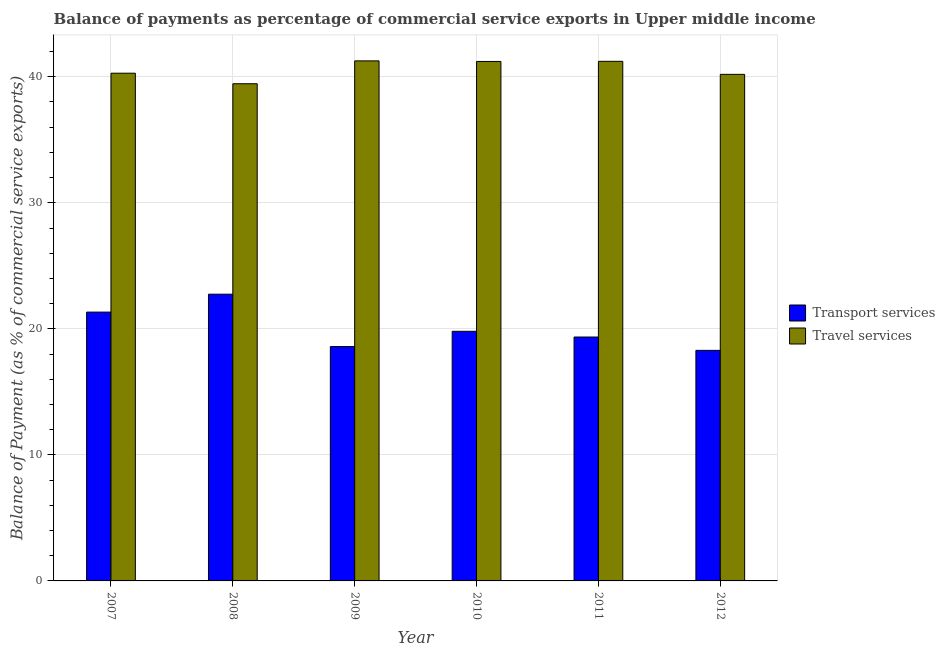How many groups of bars are there?
Provide a succinct answer. 6. Are the number of bars per tick equal to the number of legend labels?
Keep it short and to the point. Yes. Are the number of bars on each tick of the X-axis equal?
Provide a succinct answer. Yes. In how many cases, is the number of bars for a given year not equal to the number of legend labels?
Your answer should be compact. 0. What is the balance of payments of travel services in 2010?
Provide a succinct answer. 41.22. Across all years, what is the maximum balance of payments of travel services?
Your answer should be very brief. 41.26. Across all years, what is the minimum balance of payments of transport services?
Provide a succinct answer. 18.29. In which year was the balance of payments of transport services maximum?
Keep it short and to the point. 2008. In which year was the balance of payments of travel services minimum?
Provide a succinct answer. 2008. What is the total balance of payments of travel services in the graph?
Keep it short and to the point. 243.63. What is the difference between the balance of payments of travel services in 2007 and that in 2011?
Give a very brief answer. -0.94. What is the difference between the balance of payments of travel services in 2011 and the balance of payments of transport services in 2009?
Keep it short and to the point. -0.04. What is the average balance of payments of travel services per year?
Provide a short and direct response. 40.61. What is the ratio of the balance of payments of travel services in 2010 to that in 2011?
Give a very brief answer. 1. Is the balance of payments of transport services in 2011 less than that in 2012?
Give a very brief answer. No. What is the difference between the highest and the second highest balance of payments of transport services?
Provide a short and direct response. 1.42. What is the difference between the highest and the lowest balance of payments of travel services?
Offer a terse response. 1.81. In how many years, is the balance of payments of transport services greater than the average balance of payments of transport services taken over all years?
Offer a terse response. 2. What does the 1st bar from the left in 2008 represents?
Ensure brevity in your answer.  Transport services. What does the 1st bar from the right in 2007 represents?
Your answer should be very brief. Travel services. Are all the bars in the graph horizontal?
Your response must be concise. No. Are the values on the major ticks of Y-axis written in scientific E-notation?
Make the answer very short. No. Where does the legend appear in the graph?
Make the answer very short. Center right. How are the legend labels stacked?
Your answer should be compact. Vertical. What is the title of the graph?
Offer a very short reply. Balance of payments as percentage of commercial service exports in Upper middle income. What is the label or title of the X-axis?
Offer a very short reply. Year. What is the label or title of the Y-axis?
Provide a short and direct response. Balance of Payment (as % of commercial service exports). What is the Balance of Payment (as % of commercial service exports) in Transport services in 2007?
Your answer should be very brief. 21.33. What is the Balance of Payment (as % of commercial service exports) of Travel services in 2007?
Provide a succinct answer. 40.28. What is the Balance of Payment (as % of commercial service exports) in Transport services in 2008?
Offer a very short reply. 22.75. What is the Balance of Payment (as % of commercial service exports) of Travel services in 2008?
Provide a succinct answer. 39.45. What is the Balance of Payment (as % of commercial service exports) in Transport services in 2009?
Your response must be concise. 18.59. What is the Balance of Payment (as % of commercial service exports) in Travel services in 2009?
Keep it short and to the point. 41.26. What is the Balance of Payment (as % of commercial service exports) of Transport services in 2010?
Your answer should be very brief. 19.81. What is the Balance of Payment (as % of commercial service exports) of Travel services in 2010?
Offer a very short reply. 41.22. What is the Balance of Payment (as % of commercial service exports) of Transport services in 2011?
Make the answer very short. 19.35. What is the Balance of Payment (as % of commercial service exports) of Travel services in 2011?
Provide a short and direct response. 41.23. What is the Balance of Payment (as % of commercial service exports) of Transport services in 2012?
Offer a terse response. 18.29. What is the Balance of Payment (as % of commercial service exports) of Travel services in 2012?
Your response must be concise. 40.19. Across all years, what is the maximum Balance of Payment (as % of commercial service exports) in Transport services?
Provide a succinct answer. 22.75. Across all years, what is the maximum Balance of Payment (as % of commercial service exports) of Travel services?
Your answer should be very brief. 41.26. Across all years, what is the minimum Balance of Payment (as % of commercial service exports) of Transport services?
Offer a terse response. 18.29. Across all years, what is the minimum Balance of Payment (as % of commercial service exports) in Travel services?
Your answer should be very brief. 39.45. What is the total Balance of Payment (as % of commercial service exports) in Transport services in the graph?
Your response must be concise. 120.12. What is the total Balance of Payment (as % of commercial service exports) of Travel services in the graph?
Make the answer very short. 243.63. What is the difference between the Balance of Payment (as % of commercial service exports) in Transport services in 2007 and that in 2008?
Give a very brief answer. -1.42. What is the difference between the Balance of Payment (as % of commercial service exports) of Travel services in 2007 and that in 2008?
Provide a short and direct response. 0.84. What is the difference between the Balance of Payment (as % of commercial service exports) of Transport services in 2007 and that in 2009?
Your answer should be very brief. 2.73. What is the difference between the Balance of Payment (as % of commercial service exports) of Travel services in 2007 and that in 2009?
Offer a terse response. -0.98. What is the difference between the Balance of Payment (as % of commercial service exports) of Transport services in 2007 and that in 2010?
Provide a short and direct response. 1.52. What is the difference between the Balance of Payment (as % of commercial service exports) of Travel services in 2007 and that in 2010?
Give a very brief answer. -0.93. What is the difference between the Balance of Payment (as % of commercial service exports) of Transport services in 2007 and that in 2011?
Provide a short and direct response. 1.98. What is the difference between the Balance of Payment (as % of commercial service exports) in Travel services in 2007 and that in 2011?
Give a very brief answer. -0.94. What is the difference between the Balance of Payment (as % of commercial service exports) in Transport services in 2007 and that in 2012?
Offer a terse response. 3.04. What is the difference between the Balance of Payment (as % of commercial service exports) of Travel services in 2007 and that in 2012?
Your answer should be compact. 0.09. What is the difference between the Balance of Payment (as % of commercial service exports) in Transport services in 2008 and that in 2009?
Ensure brevity in your answer.  4.16. What is the difference between the Balance of Payment (as % of commercial service exports) of Travel services in 2008 and that in 2009?
Offer a terse response. -1.81. What is the difference between the Balance of Payment (as % of commercial service exports) in Transport services in 2008 and that in 2010?
Give a very brief answer. 2.94. What is the difference between the Balance of Payment (as % of commercial service exports) of Travel services in 2008 and that in 2010?
Your response must be concise. -1.77. What is the difference between the Balance of Payment (as % of commercial service exports) in Transport services in 2008 and that in 2011?
Give a very brief answer. 3.4. What is the difference between the Balance of Payment (as % of commercial service exports) of Travel services in 2008 and that in 2011?
Provide a succinct answer. -1.78. What is the difference between the Balance of Payment (as % of commercial service exports) of Transport services in 2008 and that in 2012?
Offer a very short reply. 4.46. What is the difference between the Balance of Payment (as % of commercial service exports) of Travel services in 2008 and that in 2012?
Your response must be concise. -0.75. What is the difference between the Balance of Payment (as % of commercial service exports) of Transport services in 2009 and that in 2010?
Offer a very short reply. -1.21. What is the difference between the Balance of Payment (as % of commercial service exports) in Travel services in 2009 and that in 2010?
Your answer should be compact. 0.05. What is the difference between the Balance of Payment (as % of commercial service exports) in Transport services in 2009 and that in 2011?
Give a very brief answer. -0.76. What is the difference between the Balance of Payment (as % of commercial service exports) in Travel services in 2009 and that in 2011?
Your response must be concise. 0.04. What is the difference between the Balance of Payment (as % of commercial service exports) in Transport services in 2009 and that in 2012?
Your answer should be very brief. 0.3. What is the difference between the Balance of Payment (as % of commercial service exports) of Travel services in 2009 and that in 2012?
Your answer should be compact. 1.07. What is the difference between the Balance of Payment (as % of commercial service exports) in Transport services in 2010 and that in 2011?
Keep it short and to the point. 0.45. What is the difference between the Balance of Payment (as % of commercial service exports) in Travel services in 2010 and that in 2011?
Offer a terse response. -0.01. What is the difference between the Balance of Payment (as % of commercial service exports) of Transport services in 2010 and that in 2012?
Offer a very short reply. 1.51. What is the difference between the Balance of Payment (as % of commercial service exports) in Travel services in 2010 and that in 2012?
Keep it short and to the point. 1.02. What is the difference between the Balance of Payment (as % of commercial service exports) of Transport services in 2011 and that in 2012?
Offer a very short reply. 1.06. What is the difference between the Balance of Payment (as % of commercial service exports) in Travel services in 2011 and that in 2012?
Your answer should be compact. 1.03. What is the difference between the Balance of Payment (as % of commercial service exports) of Transport services in 2007 and the Balance of Payment (as % of commercial service exports) of Travel services in 2008?
Ensure brevity in your answer.  -18.12. What is the difference between the Balance of Payment (as % of commercial service exports) in Transport services in 2007 and the Balance of Payment (as % of commercial service exports) in Travel services in 2009?
Keep it short and to the point. -19.93. What is the difference between the Balance of Payment (as % of commercial service exports) in Transport services in 2007 and the Balance of Payment (as % of commercial service exports) in Travel services in 2010?
Provide a succinct answer. -19.89. What is the difference between the Balance of Payment (as % of commercial service exports) of Transport services in 2007 and the Balance of Payment (as % of commercial service exports) of Travel services in 2011?
Your answer should be very brief. -19.9. What is the difference between the Balance of Payment (as % of commercial service exports) of Transport services in 2007 and the Balance of Payment (as % of commercial service exports) of Travel services in 2012?
Provide a succinct answer. -18.86. What is the difference between the Balance of Payment (as % of commercial service exports) of Transport services in 2008 and the Balance of Payment (as % of commercial service exports) of Travel services in 2009?
Your answer should be very brief. -18.51. What is the difference between the Balance of Payment (as % of commercial service exports) in Transport services in 2008 and the Balance of Payment (as % of commercial service exports) in Travel services in 2010?
Your answer should be compact. -18.47. What is the difference between the Balance of Payment (as % of commercial service exports) of Transport services in 2008 and the Balance of Payment (as % of commercial service exports) of Travel services in 2011?
Your answer should be very brief. -18.48. What is the difference between the Balance of Payment (as % of commercial service exports) in Transport services in 2008 and the Balance of Payment (as % of commercial service exports) in Travel services in 2012?
Your response must be concise. -17.44. What is the difference between the Balance of Payment (as % of commercial service exports) of Transport services in 2009 and the Balance of Payment (as % of commercial service exports) of Travel services in 2010?
Provide a short and direct response. -22.62. What is the difference between the Balance of Payment (as % of commercial service exports) in Transport services in 2009 and the Balance of Payment (as % of commercial service exports) in Travel services in 2011?
Give a very brief answer. -22.63. What is the difference between the Balance of Payment (as % of commercial service exports) of Transport services in 2009 and the Balance of Payment (as % of commercial service exports) of Travel services in 2012?
Ensure brevity in your answer.  -21.6. What is the difference between the Balance of Payment (as % of commercial service exports) of Transport services in 2010 and the Balance of Payment (as % of commercial service exports) of Travel services in 2011?
Provide a succinct answer. -21.42. What is the difference between the Balance of Payment (as % of commercial service exports) of Transport services in 2010 and the Balance of Payment (as % of commercial service exports) of Travel services in 2012?
Offer a terse response. -20.39. What is the difference between the Balance of Payment (as % of commercial service exports) of Transport services in 2011 and the Balance of Payment (as % of commercial service exports) of Travel services in 2012?
Your answer should be compact. -20.84. What is the average Balance of Payment (as % of commercial service exports) in Transport services per year?
Offer a terse response. 20.02. What is the average Balance of Payment (as % of commercial service exports) of Travel services per year?
Provide a short and direct response. 40.61. In the year 2007, what is the difference between the Balance of Payment (as % of commercial service exports) of Transport services and Balance of Payment (as % of commercial service exports) of Travel services?
Ensure brevity in your answer.  -18.95. In the year 2008, what is the difference between the Balance of Payment (as % of commercial service exports) in Transport services and Balance of Payment (as % of commercial service exports) in Travel services?
Provide a short and direct response. -16.7. In the year 2009, what is the difference between the Balance of Payment (as % of commercial service exports) in Transport services and Balance of Payment (as % of commercial service exports) in Travel services?
Your response must be concise. -22.67. In the year 2010, what is the difference between the Balance of Payment (as % of commercial service exports) of Transport services and Balance of Payment (as % of commercial service exports) of Travel services?
Your answer should be compact. -21.41. In the year 2011, what is the difference between the Balance of Payment (as % of commercial service exports) of Transport services and Balance of Payment (as % of commercial service exports) of Travel services?
Your answer should be very brief. -21.88. In the year 2012, what is the difference between the Balance of Payment (as % of commercial service exports) in Transport services and Balance of Payment (as % of commercial service exports) in Travel services?
Ensure brevity in your answer.  -21.9. What is the ratio of the Balance of Payment (as % of commercial service exports) of Transport services in 2007 to that in 2008?
Provide a succinct answer. 0.94. What is the ratio of the Balance of Payment (as % of commercial service exports) in Travel services in 2007 to that in 2008?
Your response must be concise. 1.02. What is the ratio of the Balance of Payment (as % of commercial service exports) in Transport services in 2007 to that in 2009?
Your response must be concise. 1.15. What is the ratio of the Balance of Payment (as % of commercial service exports) in Travel services in 2007 to that in 2009?
Provide a short and direct response. 0.98. What is the ratio of the Balance of Payment (as % of commercial service exports) in Transport services in 2007 to that in 2010?
Your response must be concise. 1.08. What is the ratio of the Balance of Payment (as % of commercial service exports) in Travel services in 2007 to that in 2010?
Offer a terse response. 0.98. What is the ratio of the Balance of Payment (as % of commercial service exports) of Transport services in 2007 to that in 2011?
Ensure brevity in your answer.  1.1. What is the ratio of the Balance of Payment (as % of commercial service exports) in Travel services in 2007 to that in 2011?
Offer a terse response. 0.98. What is the ratio of the Balance of Payment (as % of commercial service exports) in Transport services in 2007 to that in 2012?
Provide a succinct answer. 1.17. What is the ratio of the Balance of Payment (as % of commercial service exports) of Travel services in 2007 to that in 2012?
Keep it short and to the point. 1. What is the ratio of the Balance of Payment (as % of commercial service exports) of Transport services in 2008 to that in 2009?
Offer a very short reply. 1.22. What is the ratio of the Balance of Payment (as % of commercial service exports) of Travel services in 2008 to that in 2009?
Offer a very short reply. 0.96. What is the ratio of the Balance of Payment (as % of commercial service exports) of Transport services in 2008 to that in 2010?
Provide a short and direct response. 1.15. What is the ratio of the Balance of Payment (as % of commercial service exports) of Travel services in 2008 to that in 2010?
Your answer should be compact. 0.96. What is the ratio of the Balance of Payment (as % of commercial service exports) of Transport services in 2008 to that in 2011?
Give a very brief answer. 1.18. What is the ratio of the Balance of Payment (as % of commercial service exports) in Travel services in 2008 to that in 2011?
Make the answer very short. 0.96. What is the ratio of the Balance of Payment (as % of commercial service exports) in Transport services in 2008 to that in 2012?
Provide a short and direct response. 1.24. What is the ratio of the Balance of Payment (as % of commercial service exports) in Travel services in 2008 to that in 2012?
Provide a succinct answer. 0.98. What is the ratio of the Balance of Payment (as % of commercial service exports) in Transport services in 2009 to that in 2010?
Make the answer very short. 0.94. What is the ratio of the Balance of Payment (as % of commercial service exports) in Transport services in 2009 to that in 2011?
Give a very brief answer. 0.96. What is the ratio of the Balance of Payment (as % of commercial service exports) of Travel services in 2009 to that in 2011?
Offer a very short reply. 1. What is the ratio of the Balance of Payment (as % of commercial service exports) in Transport services in 2009 to that in 2012?
Provide a succinct answer. 1.02. What is the ratio of the Balance of Payment (as % of commercial service exports) in Travel services in 2009 to that in 2012?
Your answer should be very brief. 1.03. What is the ratio of the Balance of Payment (as % of commercial service exports) in Transport services in 2010 to that in 2011?
Your answer should be compact. 1.02. What is the ratio of the Balance of Payment (as % of commercial service exports) of Transport services in 2010 to that in 2012?
Make the answer very short. 1.08. What is the ratio of the Balance of Payment (as % of commercial service exports) in Travel services in 2010 to that in 2012?
Keep it short and to the point. 1.03. What is the ratio of the Balance of Payment (as % of commercial service exports) in Transport services in 2011 to that in 2012?
Provide a succinct answer. 1.06. What is the ratio of the Balance of Payment (as % of commercial service exports) of Travel services in 2011 to that in 2012?
Offer a terse response. 1.03. What is the difference between the highest and the second highest Balance of Payment (as % of commercial service exports) in Transport services?
Keep it short and to the point. 1.42. What is the difference between the highest and the second highest Balance of Payment (as % of commercial service exports) of Travel services?
Your response must be concise. 0.04. What is the difference between the highest and the lowest Balance of Payment (as % of commercial service exports) in Transport services?
Ensure brevity in your answer.  4.46. What is the difference between the highest and the lowest Balance of Payment (as % of commercial service exports) of Travel services?
Provide a short and direct response. 1.81. 